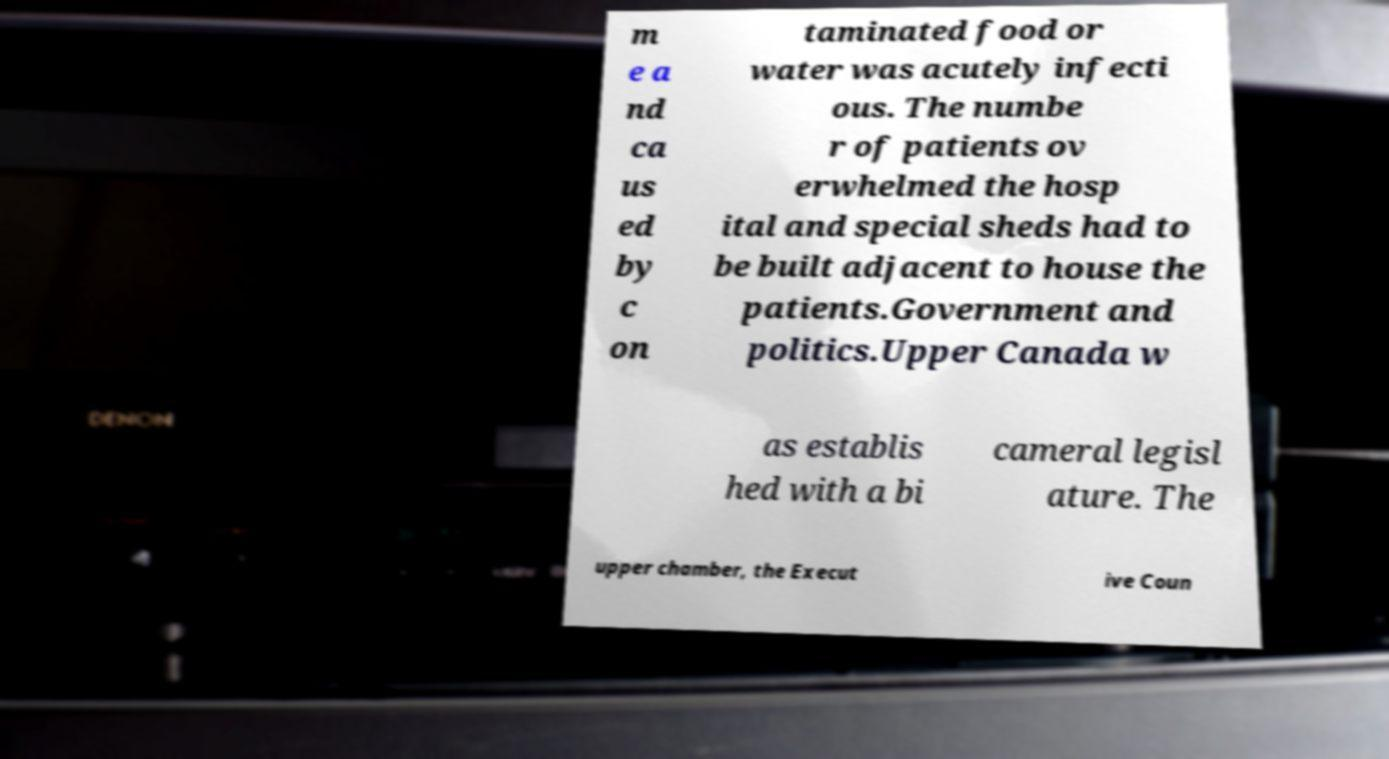Could you extract and type out the text from this image? m e a nd ca us ed by c on taminated food or water was acutely infecti ous. The numbe r of patients ov erwhelmed the hosp ital and special sheds had to be built adjacent to house the patients.Government and politics.Upper Canada w as establis hed with a bi cameral legisl ature. The upper chamber, the Execut ive Coun 